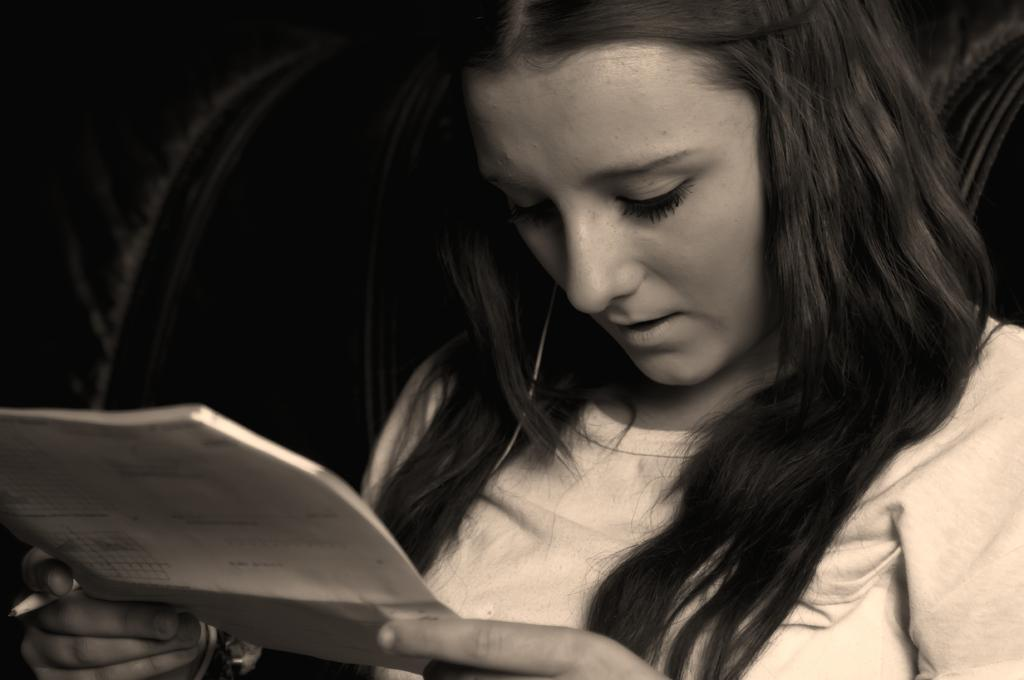What is the color scheme of the image? The image is black and white. Who is present in the image? There is a woman in the image. What is the woman holding in her hands? The woman is holding a paper and a pen. What is the woman's gaze directed towards? The woman is looking downwards. What can be seen in the background of the image? The background is black. How many lizards are crawling on the woman's shoulder in the image? There are no lizards present in the image. What type of lumber is the woman using to write on the paper? The woman is not using any lumber in the image; she is holding a pen to write on the paper. 